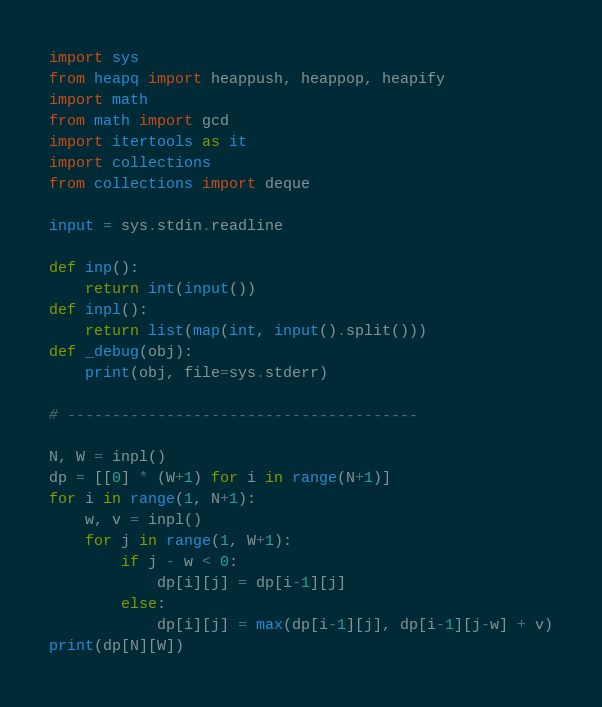<code> <loc_0><loc_0><loc_500><loc_500><_Python_>import sys
from heapq import heappush, heappop, heapify
import math
from math import gcd
import itertools as it
import collections
from collections import deque 

input = sys.stdin.readline

def inp():
    return int(input())
def inpl():
    return list(map(int, input().split()))
def _debug(obj):
    print(obj, file=sys.stderr)

# ---------------------------------------

N, W = inpl()
dp = [[0] * (W+1) for i in range(N+1)]
for i in range(1, N+1):
    w, v = inpl()
    for j in range(1, W+1):
        if j - w < 0:
            dp[i][j] = dp[i-1][j]
        else:
            dp[i][j] = max(dp[i-1][j], dp[i-1][j-w] + v)
print(dp[N][W])</code> 